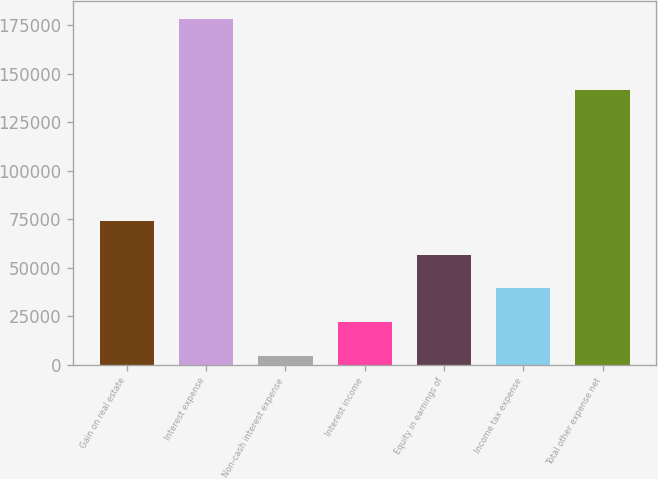Convert chart to OTSL. <chart><loc_0><loc_0><loc_500><loc_500><bar_chart><fcel>Gain on real estate<fcel>Interest expense<fcel>Non-cash interest expense<fcel>Interest income<fcel>Equity in earnings of<fcel>Income tax expense<fcel>Total other expense net<nl><fcel>74186.6<fcel>178436<fcel>4687<fcel>22061.9<fcel>56811.7<fcel>39436.8<fcel>141816<nl></chart> 